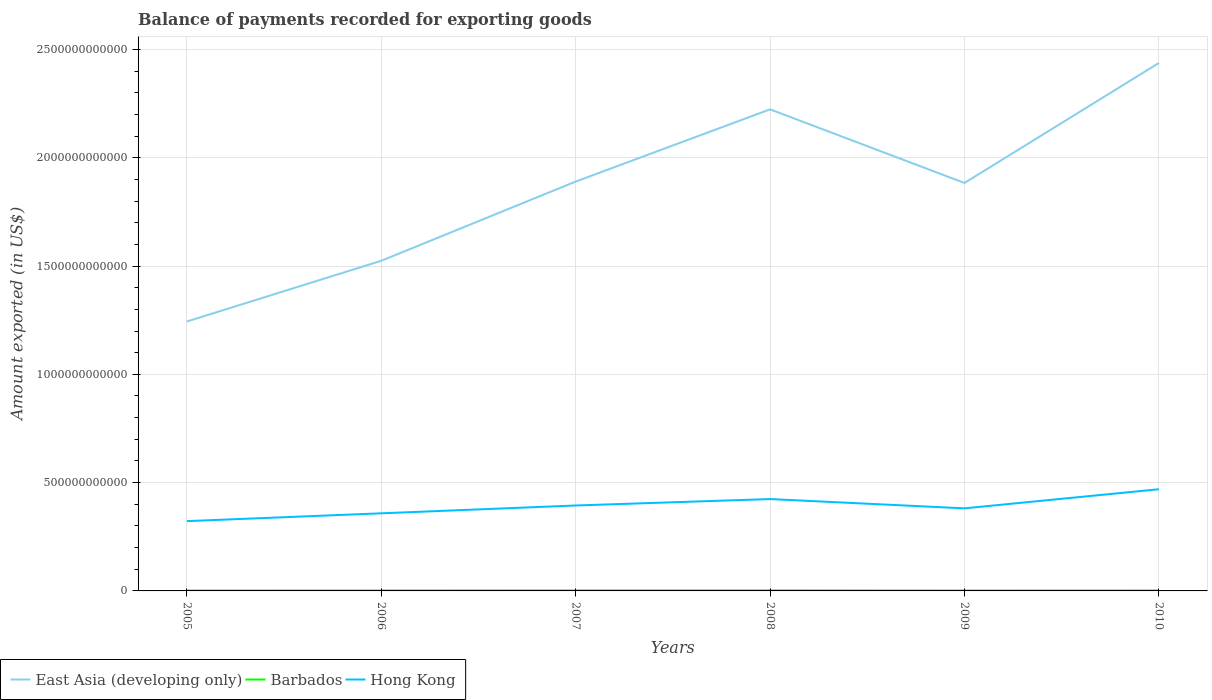Does the line corresponding to Barbados intersect with the line corresponding to Hong Kong?
Provide a succinct answer. No. Is the number of lines equal to the number of legend labels?
Provide a succinct answer. Yes. Across all years, what is the maximum amount exported in East Asia (developing only)?
Make the answer very short. 1.24e+12. What is the total amount exported in Hong Kong in the graph?
Make the answer very short. -8.81e+1. What is the difference between the highest and the second highest amount exported in East Asia (developing only)?
Keep it short and to the point. 1.19e+12. What is the difference between the highest and the lowest amount exported in Barbados?
Offer a very short reply. 3. Is the amount exported in Barbados strictly greater than the amount exported in Hong Kong over the years?
Your response must be concise. Yes. How many lines are there?
Offer a terse response. 3. What is the difference between two consecutive major ticks on the Y-axis?
Offer a very short reply. 5.00e+11. Are the values on the major ticks of Y-axis written in scientific E-notation?
Ensure brevity in your answer.  No. What is the title of the graph?
Your answer should be compact. Balance of payments recorded for exporting goods. What is the label or title of the X-axis?
Give a very brief answer. Years. What is the label or title of the Y-axis?
Your answer should be very brief. Amount exported (in US$). What is the Amount exported (in US$) in East Asia (developing only) in 2005?
Offer a terse response. 1.24e+12. What is the Amount exported (in US$) in Barbados in 2005?
Your response must be concise. 1.82e+09. What is the Amount exported (in US$) of Hong Kong in 2005?
Make the answer very short. 3.22e+11. What is the Amount exported (in US$) in East Asia (developing only) in 2006?
Offer a terse response. 1.52e+12. What is the Amount exported (in US$) of Barbados in 2006?
Ensure brevity in your answer.  2.11e+09. What is the Amount exported (in US$) in Hong Kong in 2006?
Provide a short and direct response. 3.58e+11. What is the Amount exported (in US$) of East Asia (developing only) in 2007?
Your answer should be compact. 1.89e+12. What is the Amount exported (in US$) of Barbados in 2007?
Ensure brevity in your answer.  2.23e+09. What is the Amount exported (in US$) in Hong Kong in 2007?
Make the answer very short. 3.94e+11. What is the Amount exported (in US$) in East Asia (developing only) in 2008?
Keep it short and to the point. 2.22e+12. What is the Amount exported (in US$) of Barbados in 2008?
Make the answer very short. 2.31e+09. What is the Amount exported (in US$) in Hong Kong in 2008?
Provide a succinct answer. 4.24e+11. What is the Amount exported (in US$) in East Asia (developing only) in 2009?
Keep it short and to the point. 1.88e+12. What is the Amount exported (in US$) in Barbados in 2009?
Offer a very short reply. 1.88e+09. What is the Amount exported (in US$) in Hong Kong in 2009?
Your response must be concise. 3.81e+11. What is the Amount exported (in US$) in East Asia (developing only) in 2010?
Your answer should be very brief. 2.44e+12. What is the Amount exported (in US$) in Barbados in 2010?
Offer a terse response. 2.07e+09. What is the Amount exported (in US$) of Hong Kong in 2010?
Provide a short and direct response. 4.69e+11. Across all years, what is the maximum Amount exported (in US$) in East Asia (developing only)?
Your answer should be very brief. 2.44e+12. Across all years, what is the maximum Amount exported (in US$) of Barbados?
Ensure brevity in your answer.  2.31e+09. Across all years, what is the maximum Amount exported (in US$) in Hong Kong?
Your answer should be compact. 4.69e+11. Across all years, what is the minimum Amount exported (in US$) in East Asia (developing only)?
Your answer should be compact. 1.24e+12. Across all years, what is the minimum Amount exported (in US$) of Barbados?
Keep it short and to the point. 1.82e+09. Across all years, what is the minimum Amount exported (in US$) of Hong Kong?
Make the answer very short. 3.22e+11. What is the total Amount exported (in US$) of East Asia (developing only) in the graph?
Offer a terse response. 1.12e+13. What is the total Amount exported (in US$) of Barbados in the graph?
Offer a terse response. 1.24e+1. What is the total Amount exported (in US$) in Hong Kong in the graph?
Keep it short and to the point. 2.35e+12. What is the difference between the Amount exported (in US$) of East Asia (developing only) in 2005 and that in 2006?
Your response must be concise. -2.80e+11. What is the difference between the Amount exported (in US$) of Barbados in 2005 and that in 2006?
Provide a succinct answer. -2.98e+08. What is the difference between the Amount exported (in US$) in Hong Kong in 2005 and that in 2006?
Your answer should be very brief. -3.61e+1. What is the difference between the Amount exported (in US$) in East Asia (developing only) in 2005 and that in 2007?
Your response must be concise. -6.46e+11. What is the difference between the Amount exported (in US$) of Barbados in 2005 and that in 2007?
Ensure brevity in your answer.  -4.11e+08. What is the difference between the Amount exported (in US$) of Hong Kong in 2005 and that in 2007?
Provide a succinct answer. -7.22e+1. What is the difference between the Amount exported (in US$) in East Asia (developing only) in 2005 and that in 2008?
Give a very brief answer. -9.80e+11. What is the difference between the Amount exported (in US$) in Barbados in 2005 and that in 2008?
Provide a short and direct response. -4.97e+08. What is the difference between the Amount exported (in US$) of Hong Kong in 2005 and that in 2008?
Your answer should be very brief. -1.02e+11. What is the difference between the Amount exported (in US$) in East Asia (developing only) in 2005 and that in 2009?
Your answer should be very brief. -6.40e+11. What is the difference between the Amount exported (in US$) in Barbados in 2005 and that in 2009?
Keep it short and to the point. -6.88e+07. What is the difference between the Amount exported (in US$) of Hong Kong in 2005 and that in 2009?
Provide a short and direct response. -5.90e+1. What is the difference between the Amount exported (in US$) of East Asia (developing only) in 2005 and that in 2010?
Make the answer very short. -1.19e+12. What is the difference between the Amount exported (in US$) of Barbados in 2005 and that in 2010?
Give a very brief answer. -2.54e+08. What is the difference between the Amount exported (in US$) in Hong Kong in 2005 and that in 2010?
Your response must be concise. -1.47e+11. What is the difference between the Amount exported (in US$) of East Asia (developing only) in 2006 and that in 2007?
Your response must be concise. -3.66e+11. What is the difference between the Amount exported (in US$) in Barbados in 2006 and that in 2007?
Your answer should be very brief. -1.13e+08. What is the difference between the Amount exported (in US$) of Hong Kong in 2006 and that in 2007?
Keep it short and to the point. -3.61e+1. What is the difference between the Amount exported (in US$) in East Asia (developing only) in 2006 and that in 2008?
Give a very brief answer. -6.99e+11. What is the difference between the Amount exported (in US$) in Barbados in 2006 and that in 2008?
Your answer should be compact. -1.99e+08. What is the difference between the Amount exported (in US$) in Hong Kong in 2006 and that in 2008?
Provide a short and direct response. -6.58e+1. What is the difference between the Amount exported (in US$) in East Asia (developing only) in 2006 and that in 2009?
Make the answer very short. -3.59e+11. What is the difference between the Amount exported (in US$) of Barbados in 2006 and that in 2009?
Your answer should be very brief. 2.30e+08. What is the difference between the Amount exported (in US$) in Hong Kong in 2006 and that in 2009?
Make the answer very short. -2.29e+1. What is the difference between the Amount exported (in US$) of East Asia (developing only) in 2006 and that in 2010?
Your response must be concise. -9.13e+11. What is the difference between the Amount exported (in US$) in Barbados in 2006 and that in 2010?
Your answer should be compact. 4.46e+07. What is the difference between the Amount exported (in US$) of Hong Kong in 2006 and that in 2010?
Make the answer very short. -1.11e+11. What is the difference between the Amount exported (in US$) of East Asia (developing only) in 2007 and that in 2008?
Provide a short and direct response. -3.34e+11. What is the difference between the Amount exported (in US$) in Barbados in 2007 and that in 2008?
Your answer should be very brief. -8.59e+07. What is the difference between the Amount exported (in US$) in Hong Kong in 2007 and that in 2008?
Offer a very short reply. -2.96e+1. What is the difference between the Amount exported (in US$) of East Asia (developing only) in 2007 and that in 2009?
Ensure brevity in your answer.  6.33e+09. What is the difference between the Amount exported (in US$) in Barbados in 2007 and that in 2009?
Ensure brevity in your answer.  3.42e+08. What is the difference between the Amount exported (in US$) in Hong Kong in 2007 and that in 2009?
Make the answer very short. 1.32e+1. What is the difference between the Amount exported (in US$) of East Asia (developing only) in 2007 and that in 2010?
Keep it short and to the point. -5.48e+11. What is the difference between the Amount exported (in US$) in Barbados in 2007 and that in 2010?
Provide a succinct answer. 1.57e+08. What is the difference between the Amount exported (in US$) in Hong Kong in 2007 and that in 2010?
Provide a short and direct response. -7.50e+1. What is the difference between the Amount exported (in US$) of East Asia (developing only) in 2008 and that in 2009?
Ensure brevity in your answer.  3.40e+11. What is the difference between the Amount exported (in US$) of Barbados in 2008 and that in 2009?
Provide a succinct answer. 4.28e+08. What is the difference between the Amount exported (in US$) of Hong Kong in 2008 and that in 2009?
Make the answer very short. 4.28e+1. What is the difference between the Amount exported (in US$) of East Asia (developing only) in 2008 and that in 2010?
Give a very brief answer. -2.14e+11. What is the difference between the Amount exported (in US$) in Barbados in 2008 and that in 2010?
Your answer should be compact. 2.43e+08. What is the difference between the Amount exported (in US$) of Hong Kong in 2008 and that in 2010?
Offer a very short reply. -4.53e+1. What is the difference between the Amount exported (in US$) of East Asia (developing only) in 2009 and that in 2010?
Ensure brevity in your answer.  -5.54e+11. What is the difference between the Amount exported (in US$) in Barbados in 2009 and that in 2010?
Keep it short and to the point. -1.85e+08. What is the difference between the Amount exported (in US$) of Hong Kong in 2009 and that in 2010?
Offer a terse response. -8.81e+1. What is the difference between the Amount exported (in US$) of East Asia (developing only) in 2005 and the Amount exported (in US$) of Barbados in 2006?
Your response must be concise. 1.24e+12. What is the difference between the Amount exported (in US$) of East Asia (developing only) in 2005 and the Amount exported (in US$) of Hong Kong in 2006?
Your response must be concise. 8.85e+11. What is the difference between the Amount exported (in US$) of Barbados in 2005 and the Amount exported (in US$) of Hong Kong in 2006?
Provide a succinct answer. -3.57e+11. What is the difference between the Amount exported (in US$) of East Asia (developing only) in 2005 and the Amount exported (in US$) of Barbados in 2007?
Your response must be concise. 1.24e+12. What is the difference between the Amount exported (in US$) of East Asia (developing only) in 2005 and the Amount exported (in US$) of Hong Kong in 2007?
Provide a short and direct response. 8.49e+11. What is the difference between the Amount exported (in US$) of Barbados in 2005 and the Amount exported (in US$) of Hong Kong in 2007?
Offer a terse response. -3.93e+11. What is the difference between the Amount exported (in US$) in East Asia (developing only) in 2005 and the Amount exported (in US$) in Barbados in 2008?
Your answer should be very brief. 1.24e+12. What is the difference between the Amount exported (in US$) in East Asia (developing only) in 2005 and the Amount exported (in US$) in Hong Kong in 2008?
Offer a very short reply. 8.20e+11. What is the difference between the Amount exported (in US$) in Barbados in 2005 and the Amount exported (in US$) in Hong Kong in 2008?
Ensure brevity in your answer.  -4.22e+11. What is the difference between the Amount exported (in US$) in East Asia (developing only) in 2005 and the Amount exported (in US$) in Barbados in 2009?
Your response must be concise. 1.24e+12. What is the difference between the Amount exported (in US$) of East Asia (developing only) in 2005 and the Amount exported (in US$) of Hong Kong in 2009?
Your response must be concise. 8.63e+11. What is the difference between the Amount exported (in US$) in Barbados in 2005 and the Amount exported (in US$) in Hong Kong in 2009?
Give a very brief answer. -3.79e+11. What is the difference between the Amount exported (in US$) of East Asia (developing only) in 2005 and the Amount exported (in US$) of Barbados in 2010?
Give a very brief answer. 1.24e+12. What is the difference between the Amount exported (in US$) in East Asia (developing only) in 2005 and the Amount exported (in US$) in Hong Kong in 2010?
Your response must be concise. 7.74e+11. What is the difference between the Amount exported (in US$) in Barbados in 2005 and the Amount exported (in US$) in Hong Kong in 2010?
Your response must be concise. -4.68e+11. What is the difference between the Amount exported (in US$) of East Asia (developing only) in 2006 and the Amount exported (in US$) of Barbados in 2007?
Keep it short and to the point. 1.52e+12. What is the difference between the Amount exported (in US$) in East Asia (developing only) in 2006 and the Amount exported (in US$) in Hong Kong in 2007?
Ensure brevity in your answer.  1.13e+12. What is the difference between the Amount exported (in US$) in Barbados in 2006 and the Amount exported (in US$) in Hong Kong in 2007?
Offer a terse response. -3.92e+11. What is the difference between the Amount exported (in US$) in East Asia (developing only) in 2006 and the Amount exported (in US$) in Barbados in 2008?
Offer a very short reply. 1.52e+12. What is the difference between the Amount exported (in US$) in East Asia (developing only) in 2006 and the Amount exported (in US$) in Hong Kong in 2008?
Your response must be concise. 1.10e+12. What is the difference between the Amount exported (in US$) of Barbados in 2006 and the Amount exported (in US$) of Hong Kong in 2008?
Provide a succinct answer. -4.22e+11. What is the difference between the Amount exported (in US$) of East Asia (developing only) in 2006 and the Amount exported (in US$) of Barbados in 2009?
Ensure brevity in your answer.  1.52e+12. What is the difference between the Amount exported (in US$) of East Asia (developing only) in 2006 and the Amount exported (in US$) of Hong Kong in 2009?
Your answer should be compact. 1.14e+12. What is the difference between the Amount exported (in US$) of Barbados in 2006 and the Amount exported (in US$) of Hong Kong in 2009?
Your answer should be compact. -3.79e+11. What is the difference between the Amount exported (in US$) of East Asia (developing only) in 2006 and the Amount exported (in US$) of Barbados in 2010?
Ensure brevity in your answer.  1.52e+12. What is the difference between the Amount exported (in US$) in East Asia (developing only) in 2006 and the Amount exported (in US$) in Hong Kong in 2010?
Give a very brief answer. 1.05e+12. What is the difference between the Amount exported (in US$) of Barbados in 2006 and the Amount exported (in US$) of Hong Kong in 2010?
Keep it short and to the point. -4.67e+11. What is the difference between the Amount exported (in US$) of East Asia (developing only) in 2007 and the Amount exported (in US$) of Barbados in 2008?
Give a very brief answer. 1.89e+12. What is the difference between the Amount exported (in US$) in East Asia (developing only) in 2007 and the Amount exported (in US$) in Hong Kong in 2008?
Offer a terse response. 1.47e+12. What is the difference between the Amount exported (in US$) in Barbados in 2007 and the Amount exported (in US$) in Hong Kong in 2008?
Provide a succinct answer. -4.22e+11. What is the difference between the Amount exported (in US$) of East Asia (developing only) in 2007 and the Amount exported (in US$) of Barbados in 2009?
Your answer should be very brief. 1.89e+12. What is the difference between the Amount exported (in US$) in East Asia (developing only) in 2007 and the Amount exported (in US$) in Hong Kong in 2009?
Provide a succinct answer. 1.51e+12. What is the difference between the Amount exported (in US$) in Barbados in 2007 and the Amount exported (in US$) in Hong Kong in 2009?
Your answer should be compact. -3.79e+11. What is the difference between the Amount exported (in US$) of East Asia (developing only) in 2007 and the Amount exported (in US$) of Barbados in 2010?
Your answer should be very brief. 1.89e+12. What is the difference between the Amount exported (in US$) of East Asia (developing only) in 2007 and the Amount exported (in US$) of Hong Kong in 2010?
Ensure brevity in your answer.  1.42e+12. What is the difference between the Amount exported (in US$) in Barbados in 2007 and the Amount exported (in US$) in Hong Kong in 2010?
Your answer should be very brief. -4.67e+11. What is the difference between the Amount exported (in US$) of East Asia (developing only) in 2008 and the Amount exported (in US$) of Barbados in 2009?
Keep it short and to the point. 2.22e+12. What is the difference between the Amount exported (in US$) in East Asia (developing only) in 2008 and the Amount exported (in US$) in Hong Kong in 2009?
Give a very brief answer. 1.84e+12. What is the difference between the Amount exported (in US$) of Barbados in 2008 and the Amount exported (in US$) of Hong Kong in 2009?
Offer a very short reply. -3.79e+11. What is the difference between the Amount exported (in US$) in East Asia (developing only) in 2008 and the Amount exported (in US$) in Barbados in 2010?
Your response must be concise. 2.22e+12. What is the difference between the Amount exported (in US$) in East Asia (developing only) in 2008 and the Amount exported (in US$) in Hong Kong in 2010?
Offer a terse response. 1.75e+12. What is the difference between the Amount exported (in US$) in Barbados in 2008 and the Amount exported (in US$) in Hong Kong in 2010?
Your answer should be compact. -4.67e+11. What is the difference between the Amount exported (in US$) of East Asia (developing only) in 2009 and the Amount exported (in US$) of Barbados in 2010?
Give a very brief answer. 1.88e+12. What is the difference between the Amount exported (in US$) in East Asia (developing only) in 2009 and the Amount exported (in US$) in Hong Kong in 2010?
Keep it short and to the point. 1.41e+12. What is the difference between the Amount exported (in US$) of Barbados in 2009 and the Amount exported (in US$) of Hong Kong in 2010?
Your answer should be very brief. -4.68e+11. What is the average Amount exported (in US$) of East Asia (developing only) per year?
Make the answer very short. 1.87e+12. What is the average Amount exported (in US$) in Barbados per year?
Keep it short and to the point. 2.07e+09. What is the average Amount exported (in US$) in Hong Kong per year?
Give a very brief answer. 3.92e+11. In the year 2005, what is the difference between the Amount exported (in US$) of East Asia (developing only) and Amount exported (in US$) of Barbados?
Offer a terse response. 1.24e+12. In the year 2005, what is the difference between the Amount exported (in US$) in East Asia (developing only) and Amount exported (in US$) in Hong Kong?
Keep it short and to the point. 9.22e+11. In the year 2005, what is the difference between the Amount exported (in US$) in Barbados and Amount exported (in US$) in Hong Kong?
Your answer should be compact. -3.20e+11. In the year 2006, what is the difference between the Amount exported (in US$) of East Asia (developing only) and Amount exported (in US$) of Barbados?
Ensure brevity in your answer.  1.52e+12. In the year 2006, what is the difference between the Amount exported (in US$) in East Asia (developing only) and Amount exported (in US$) in Hong Kong?
Offer a terse response. 1.17e+12. In the year 2006, what is the difference between the Amount exported (in US$) of Barbados and Amount exported (in US$) of Hong Kong?
Your answer should be very brief. -3.56e+11. In the year 2007, what is the difference between the Amount exported (in US$) in East Asia (developing only) and Amount exported (in US$) in Barbados?
Offer a terse response. 1.89e+12. In the year 2007, what is the difference between the Amount exported (in US$) in East Asia (developing only) and Amount exported (in US$) in Hong Kong?
Provide a succinct answer. 1.50e+12. In the year 2007, what is the difference between the Amount exported (in US$) in Barbados and Amount exported (in US$) in Hong Kong?
Ensure brevity in your answer.  -3.92e+11. In the year 2008, what is the difference between the Amount exported (in US$) in East Asia (developing only) and Amount exported (in US$) in Barbados?
Give a very brief answer. 2.22e+12. In the year 2008, what is the difference between the Amount exported (in US$) of East Asia (developing only) and Amount exported (in US$) of Hong Kong?
Keep it short and to the point. 1.80e+12. In the year 2008, what is the difference between the Amount exported (in US$) of Barbados and Amount exported (in US$) of Hong Kong?
Provide a succinct answer. -4.22e+11. In the year 2009, what is the difference between the Amount exported (in US$) in East Asia (developing only) and Amount exported (in US$) in Barbados?
Offer a terse response. 1.88e+12. In the year 2009, what is the difference between the Amount exported (in US$) of East Asia (developing only) and Amount exported (in US$) of Hong Kong?
Your response must be concise. 1.50e+12. In the year 2009, what is the difference between the Amount exported (in US$) of Barbados and Amount exported (in US$) of Hong Kong?
Your response must be concise. -3.79e+11. In the year 2010, what is the difference between the Amount exported (in US$) in East Asia (developing only) and Amount exported (in US$) in Barbados?
Offer a terse response. 2.44e+12. In the year 2010, what is the difference between the Amount exported (in US$) in East Asia (developing only) and Amount exported (in US$) in Hong Kong?
Offer a terse response. 1.97e+12. In the year 2010, what is the difference between the Amount exported (in US$) in Barbados and Amount exported (in US$) in Hong Kong?
Ensure brevity in your answer.  -4.67e+11. What is the ratio of the Amount exported (in US$) of East Asia (developing only) in 2005 to that in 2006?
Your answer should be very brief. 0.82. What is the ratio of the Amount exported (in US$) in Barbados in 2005 to that in 2006?
Your answer should be very brief. 0.86. What is the ratio of the Amount exported (in US$) in Hong Kong in 2005 to that in 2006?
Provide a short and direct response. 0.9. What is the ratio of the Amount exported (in US$) of East Asia (developing only) in 2005 to that in 2007?
Make the answer very short. 0.66. What is the ratio of the Amount exported (in US$) of Barbados in 2005 to that in 2007?
Make the answer very short. 0.82. What is the ratio of the Amount exported (in US$) in Hong Kong in 2005 to that in 2007?
Ensure brevity in your answer.  0.82. What is the ratio of the Amount exported (in US$) in East Asia (developing only) in 2005 to that in 2008?
Provide a short and direct response. 0.56. What is the ratio of the Amount exported (in US$) of Barbados in 2005 to that in 2008?
Offer a terse response. 0.79. What is the ratio of the Amount exported (in US$) in Hong Kong in 2005 to that in 2008?
Make the answer very short. 0.76. What is the ratio of the Amount exported (in US$) of East Asia (developing only) in 2005 to that in 2009?
Ensure brevity in your answer.  0.66. What is the ratio of the Amount exported (in US$) of Barbados in 2005 to that in 2009?
Provide a succinct answer. 0.96. What is the ratio of the Amount exported (in US$) of Hong Kong in 2005 to that in 2009?
Provide a succinct answer. 0.85. What is the ratio of the Amount exported (in US$) in East Asia (developing only) in 2005 to that in 2010?
Give a very brief answer. 0.51. What is the ratio of the Amount exported (in US$) of Barbados in 2005 to that in 2010?
Your response must be concise. 0.88. What is the ratio of the Amount exported (in US$) of Hong Kong in 2005 to that in 2010?
Your answer should be very brief. 0.69. What is the ratio of the Amount exported (in US$) in East Asia (developing only) in 2006 to that in 2007?
Provide a succinct answer. 0.81. What is the ratio of the Amount exported (in US$) of Barbados in 2006 to that in 2007?
Keep it short and to the point. 0.95. What is the ratio of the Amount exported (in US$) of Hong Kong in 2006 to that in 2007?
Give a very brief answer. 0.91. What is the ratio of the Amount exported (in US$) in East Asia (developing only) in 2006 to that in 2008?
Your answer should be very brief. 0.69. What is the ratio of the Amount exported (in US$) in Barbados in 2006 to that in 2008?
Your answer should be compact. 0.91. What is the ratio of the Amount exported (in US$) in Hong Kong in 2006 to that in 2008?
Ensure brevity in your answer.  0.84. What is the ratio of the Amount exported (in US$) of East Asia (developing only) in 2006 to that in 2009?
Provide a succinct answer. 0.81. What is the ratio of the Amount exported (in US$) of Barbados in 2006 to that in 2009?
Offer a very short reply. 1.12. What is the ratio of the Amount exported (in US$) of Hong Kong in 2006 to that in 2009?
Offer a terse response. 0.94. What is the ratio of the Amount exported (in US$) of East Asia (developing only) in 2006 to that in 2010?
Your response must be concise. 0.63. What is the ratio of the Amount exported (in US$) of Barbados in 2006 to that in 2010?
Your response must be concise. 1.02. What is the ratio of the Amount exported (in US$) of Hong Kong in 2006 to that in 2010?
Provide a succinct answer. 0.76. What is the ratio of the Amount exported (in US$) in East Asia (developing only) in 2007 to that in 2008?
Keep it short and to the point. 0.85. What is the ratio of the Amount exported (in US$) in Barbados in 2007 to that in 2008?
Offer a very short reply. 0.96. What is the ratio of the Amount exported (in US$) in Hong Kong in 2007 to that in 2008?
Offer a terse response. 0.93. What is the ratio of the Amount exported (in US$) of Barbados in 2007 to that in 2009?
Offer a very short reply. 1.18. What is the ratio of the Amount exported (in US$) in Hong Kong in 2007 to that in 2009?
Your answer should be very brief. 1.03. What is the ratio of the Amount exported (in US$) of East Asia (developing only) in 2007 to that in 2010?
Give a very brief answer. 0.78. What is the ratio of the Amount exported (in US$) in Barbados in 2007 to that in 2010?
Provide a succinct answer. 1.08. What is the ratio of the Amount exported (in US$) of Hong Kong in 2007 to that in 2010?
Ensure brevity in your answer.  0.84. What is the ratio of the Amount exported (in US$) in East Asia (developing only) in 2008 to that in 2009?
Ensure brevity in your answer.  1.18. What is the ratio of the Amount exported (in US$) of Barbados in 2008 to that in 2009?
Your response must be concise. 1.23. What is the ratio of the Amount exported (in US$) in Hong Kong in 2008 to that in 2009?
Give a very brief answer. 1.11. What is the ratio of the Amount exported (in US$) in East Asia (developing only) in 2008 to that in 2010?
Offer a very short reply. 0.91. What is the ratio of the Amount exported (in US$) in Barbados in 2008 to that in 2010?
Your response must be concise. 1.12. What is the ratio of the Amount exported (in US$) in Hong Kong in 2008 to that in 2010?
Provide a short and direct response. 0.9. What is the ratio of the Amount exported (in US$) in East Asia (developing only) in 2009 to that in 2010?
Your answer should be compact. 0.77. What is the ratio of the Amount exported (in US$) in Barbados in 2009 to that in 2010?
Offer a very short reply. 0.91. What is the ratio of the Amount exported (in US$) of Hong Kong in 2009 to that in 2010?
Keep it short and to the point. 0.81. What is the difference between the highest and the second highest Amount exported (in US$) of East Asia (developing only)?
Ensure brevity in your answer.  2.14e+11. What is the difference between the highest and the second highest Amount exported (in US$) in Barbados?
Provide a short and direct response. 8.59e+07. What is the difference between the highest and the second highest Amount exported (in US$) of Hong Kong?
Your answer should be compact. 4.53e+1. What is the difference between the highest and the lowest Amount exported (in US$) in East Asia (developing only)?
Ensure brevity in your answer.  1.19e+12. What is the difference between the highest and the lowest Amount exported (in US$) of Barbados?
Make the answer very short. 4.97e+08. What is the difference between the highest and the lowest Amount exported (in US$) in Hong Kong?
Give a very brief answer. 1.47e+11. 